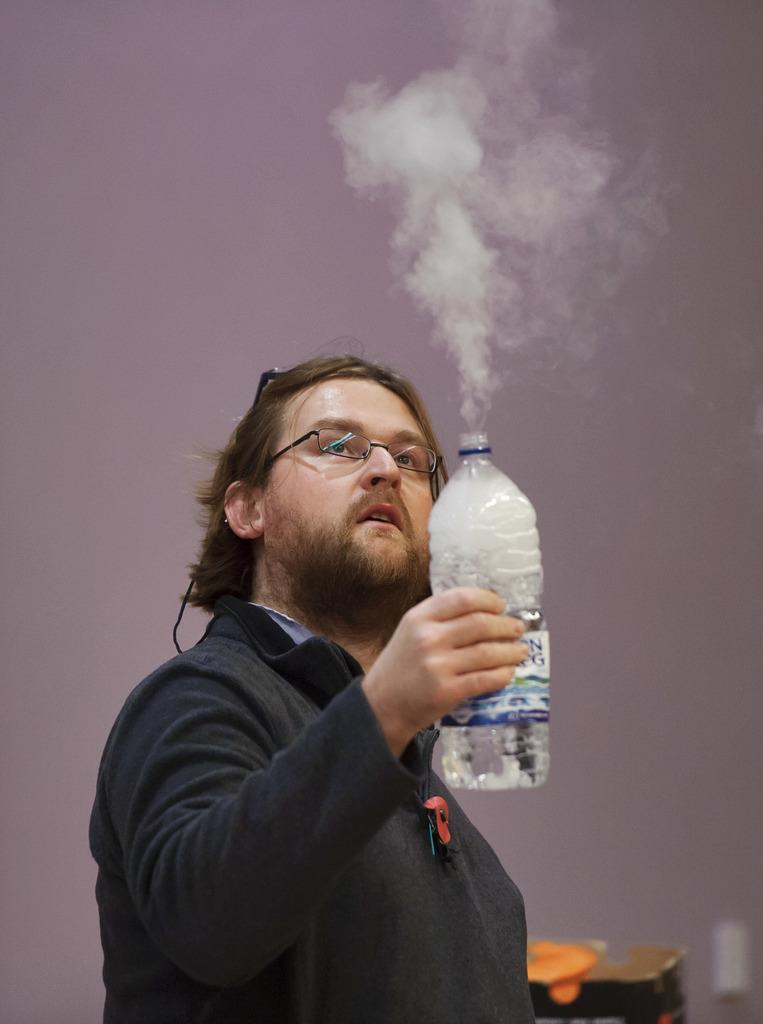Describe this image in one or two sentences. In this picture we can see man wore spectacle holding bottle in his hand and in background we can see wall, table. 